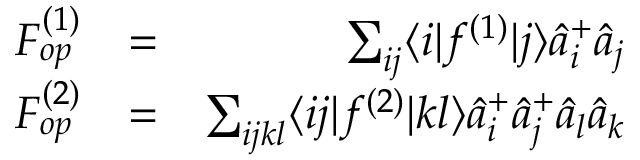Convert formula to latex. <formula><loc_0><loc_0><loc_500><loc_500>\begin{array} { r l r } { F _ { o p } ^ { ( 1 ) } } & { = } & { \sum _ { i j } \langle i | f ^ { ( 1 ) } | j \rangle \hat { a } _ { i } ^ { + } \hat { a } _ { j } } \\ { F _ { o p } ^ { ( 2 ) } } & { = } & { \sum _ { i j k l } \langle i j | f ^ { ( 2 ) } | k l \rangle \hat { a } _ { i } ^ { + } \hat { a } _ { j } ^ { + } \hat { a } _ { l } \hat { a } _ { k } } \end{array}</formula> 